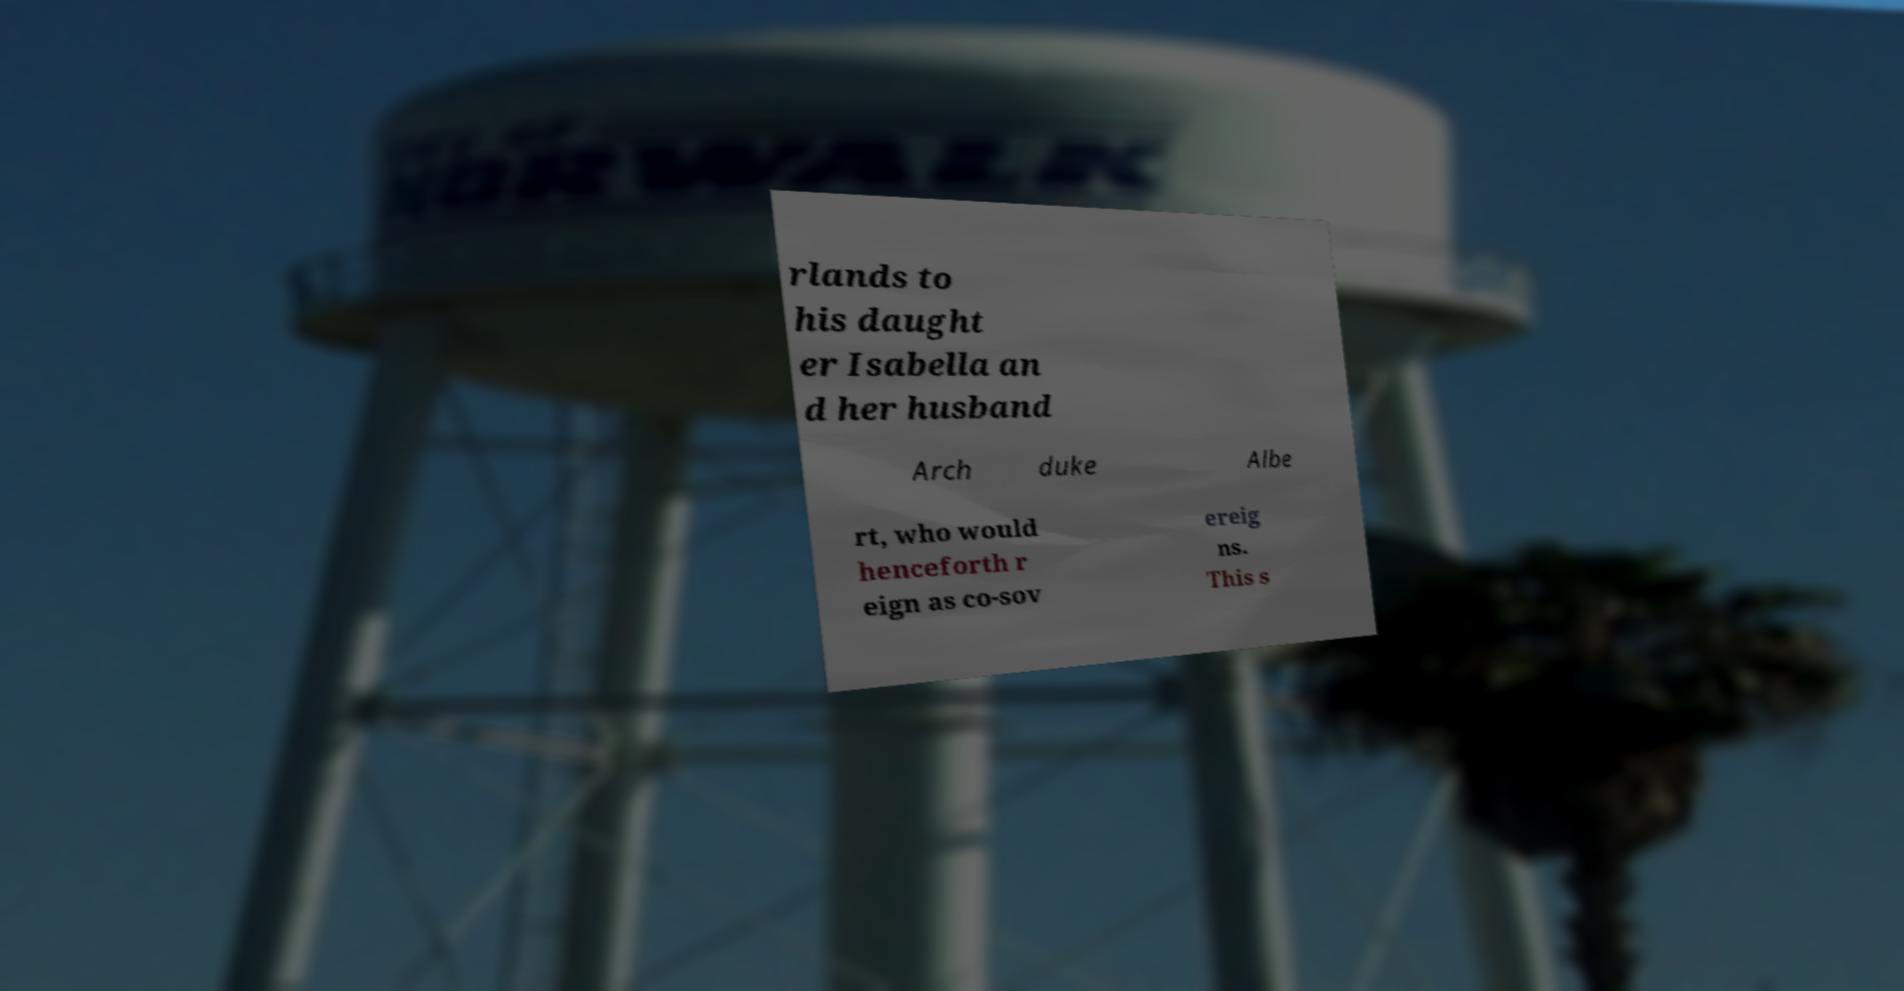There's text embedded in this image that I need extracted. Can you transcribe it verbatim? rlands to his daught er Isabella an d her husband Arch duke Albe rt, who would henceforth r eign as co-sov ereig ns. This s 